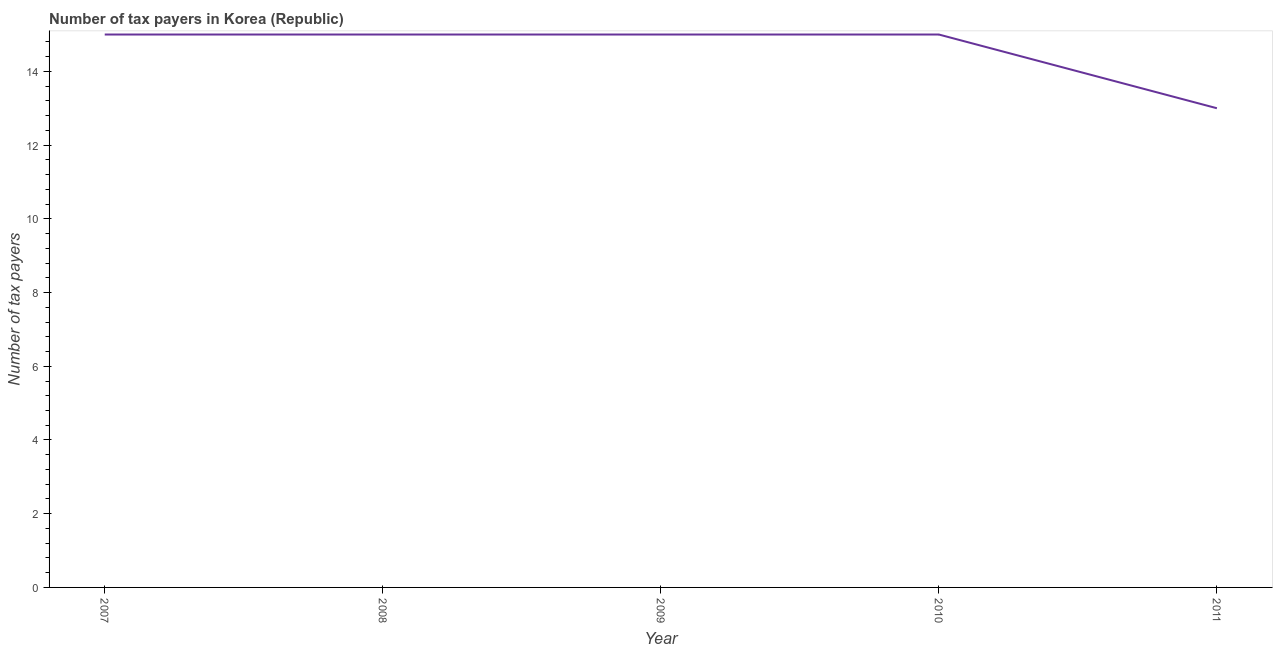What is the number of tax payers in 2008?
Make the answer very short. 15. Across all years, what is the maximum number of tax payers?
Your response must be concise. 15. Across all years, what is the minimum number of tax payers?
Offer a terse response. 13. In which year was the number of tax payers maximum?
Ensure brevity in your answer.  2007. What is the sum of the number of tax payers?
Offer a terse response. 73. What is the difference between the number of tax payers in 2008 and 2010?
Offer a very short reply. 0. What is the average number of tax payers per year?
Make the answer very short. 14.6. Do a majority of the years between 2011 and 2007 (inclusive) have number of tax payers greater than 12.8 ?
Keep it short and to the point. Yes. What is the ratio of the number of tax payers in 2007 to that in 2011?
Ensure brevity in your answer.  1.15. Is the number of tax payers in 2007 less than that in 2010?
Your answer should be very brief. No. Is the difference between the number of tax payers in 2008 and 2011 greater than the difference between any two years?
Offer a very short reply. Yes. What is the difference between the highest and the lowest number of tax payers?
Your response must be concise. 2. Does the number of tax payers monotonically increase over the years?
Your answer should be compact. No. Does the graph contain grids?
Your answer should be very brief. No. What is the title of the graph?
Your response must be concise. Number of tax payers in Korea (Republic). What is the label or title of the Y-axis?
Give a very brief answer. Number of tax payers. What is the Number of tax payers in 2008?
Your answer should be compact. 15. What is the Number of tax payers in 2009?
Provide a succinct answer. 15. What is the difference between the Number of tax payers in 2007 and 2010?
Keep it short and to the point. 0. What is the difference between the Number of tax payers in 2007 and 2011?
Provide a short and direct response. 2. What is the difference between the Number of tax payers in 2008 and 2011?
Offer a terse response. 2. What is the difference between the Number of tax payers in 2009 and 2010?
Keep it short and to the point. 0. What is the difference between the Number of tax payers in 2009 and 2011?
Provide a succinct answer. 2. What is the ratio of the Number of tax payers in 2007 to that in 2008?
Give a very brief answer. 1. What is the ratio of the Number of tax payers in 2007 to that in 2009?
Your answer should be compact. 1. What is the ratio of the Number of tax payers in 2007 to that in 2010?
Ensure brevity in your answer.  1. What is the ratio of the Number of tax payers in 2007 to that in 2011?
Keep it short and to the point. 1.15. What is the ratio of the Number of tax payers in 2008 to that in 2011?
Your answer should be compact. 1.15. What is the ratio of the Number of tax payers in 2009 to that in 2011?
Your response must be concise. 1.15. What is the ratio of the Number of tax payers in 2010 to that in 2011?
Ensure brevity in your answer.  1.15. 